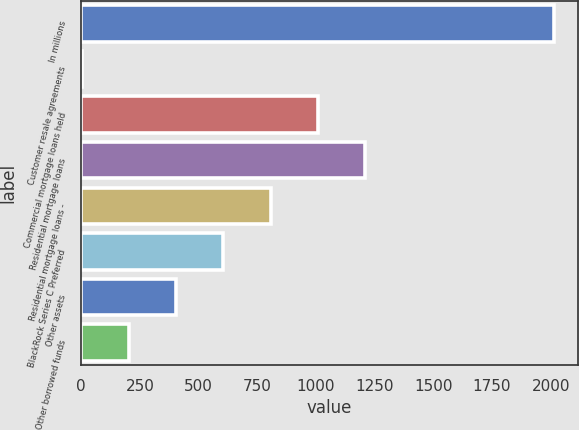Convert chart to OTSL. <chart><loc_0><loc_0><loc_500><loc_500><bar_chart><fcel>In millions<fcel>Customer resale agreements<fcel>Commercial mortgage loans held<fcel>Residential mortgage loans<fcel>Residential mortgage loans -<fcel>BlackRock Series C Preferred<fcel>Other assets<fcel>Other borrowed funds<nl><fcel>2015<fcel>2<fcel>1008.5<fcel>1209.8<fcel>807.2<fcel>605.9<fcel>404.6<fcel>203.3<nl></chart> 